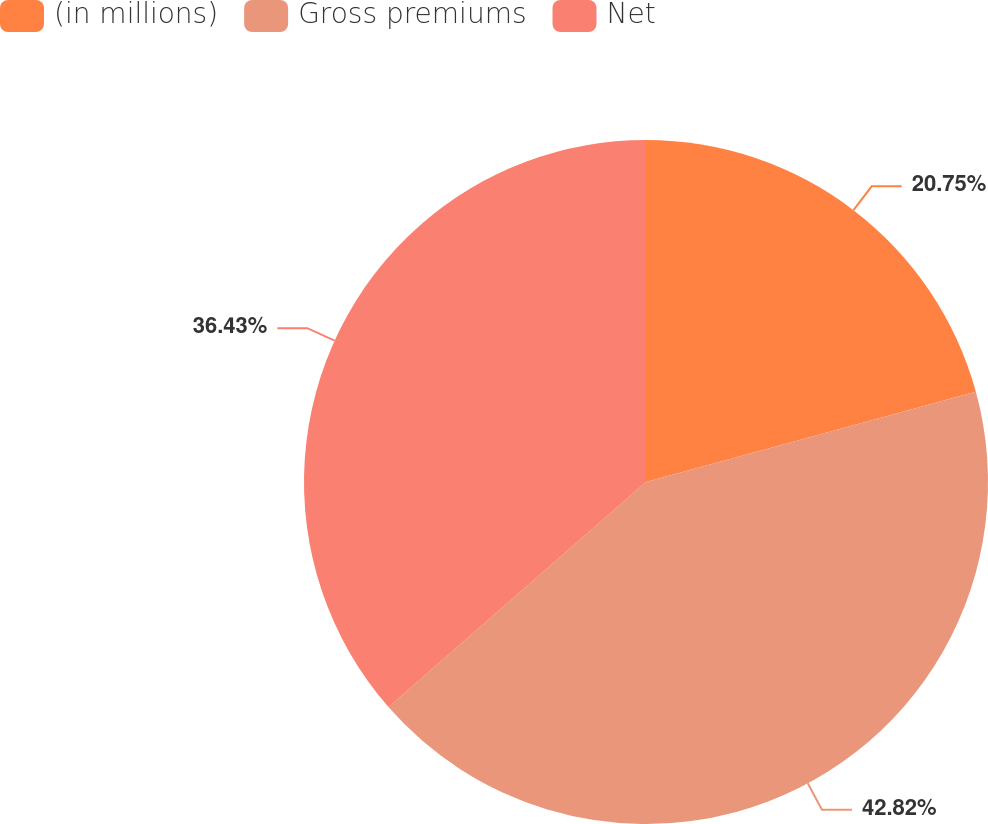Convert chart to OTSL. <chart><loc_0><loc_0><loc_500><loc_500><pie_chart><fcel>(in millions)<fcel>Gross premiums<fcel>Net<nl><fcel>20.75%<fcel>42.82%<fcel>36.43%<nl></chart> 